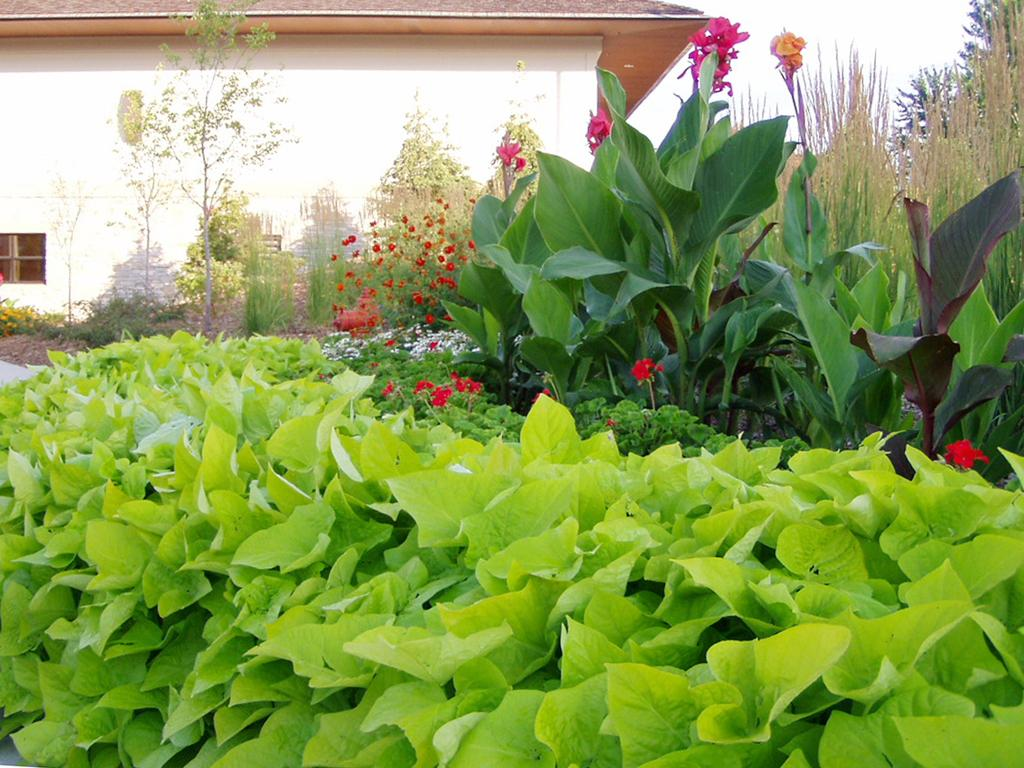What type of vegetation can be seen in the image? There are plants and a tree in the image. What is visible in the background of the image? There is a building in the background of the image. What letter does the tree in the image spell out? The tree in the image does not spell out any letters; it is a natural object and not a form of communication. 